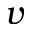<formula> <loc_0><loc_0><loc_500><loc_500>v</formula> 